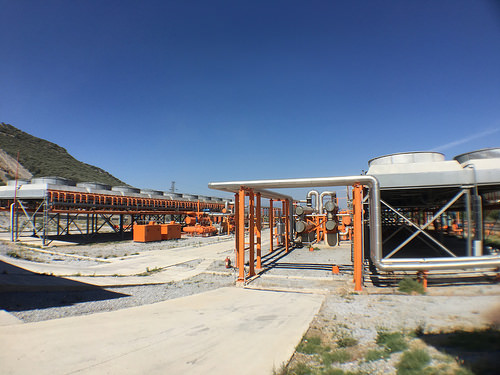<image>
Is there a box in front of the platform? Yes. The box is positioned in front of the platform, appearing closer to the camera viewpoint. 